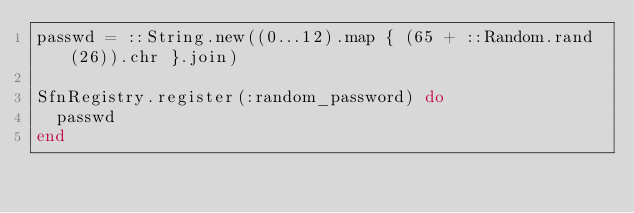Convert code to text. <code><loc_0><loc_0><loc_500><loc_500><_Ruby_>passwd = ::String.new((0...12).map { (65 + ::Random.rand(26)).chr }.join)

SfnRegistry.register(:random_password) do
  passwd
end
</code> 